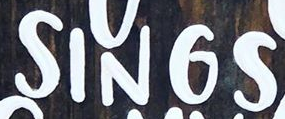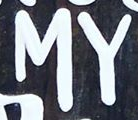Read the text from these images in sequence, separated by a semicolon. SINGS; MY 